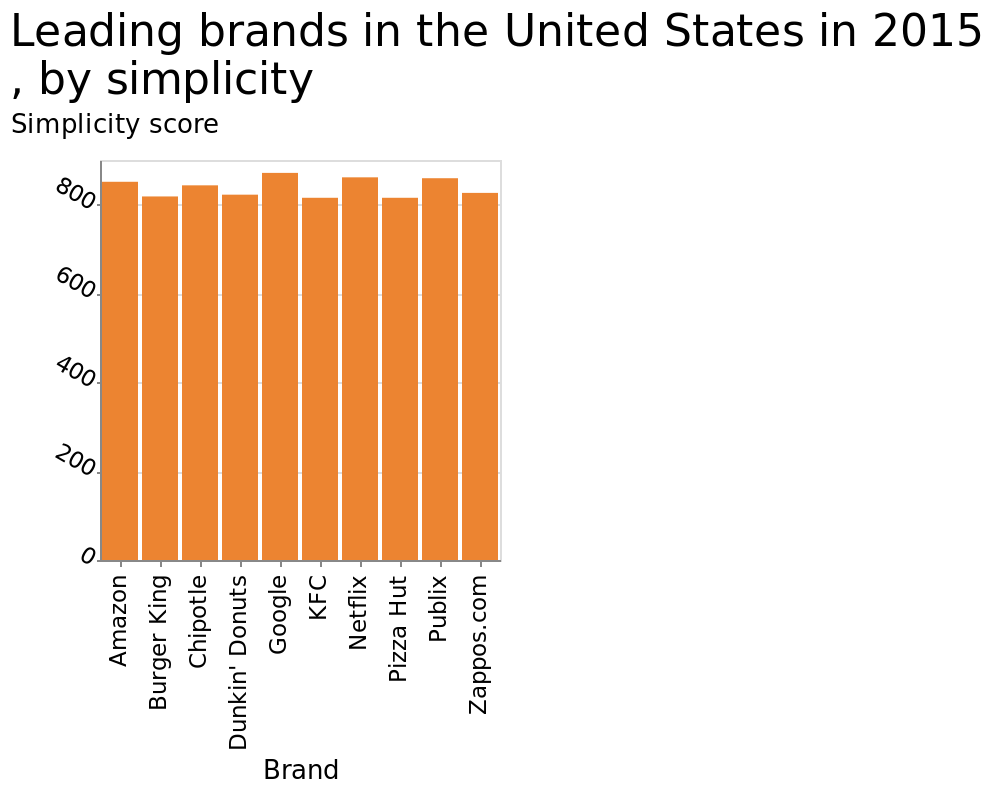<image>
Describe the following image in detail This is a bar plot titled Leading brands in the United States in 2015 , by simplicity. The x-axis shows Brand using categorical scale from Amazon to Zappos.com while the y-axis plots Simplicity score using linear scale of range 0 to 800. 